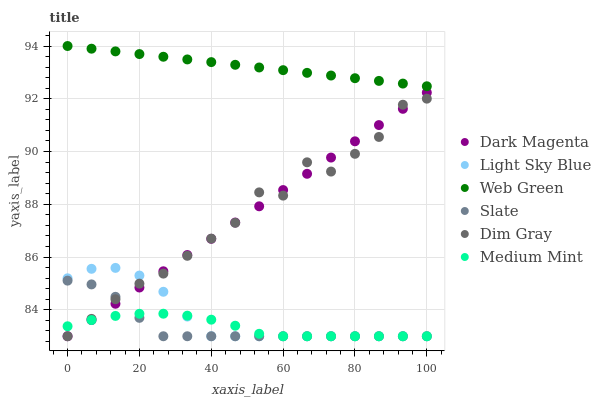Does Medium Mint have the minimum area under the curve?
Answer yes or no. Yes. Does Web Green have the maximum area under the curve?
Answer yes or no. Yes. Does Dim Gray have the minimum area under the curve?
Answer yes or no. No. Does Dim Gray have the maximum area under the curve?
Answer yes or no. No. Is Dark Magenta the smoothest?
Answer yes or no. Yes. Is Dim Gray the roughest?
Answer yes or no. Yes. Is Dim Gray the smoothest?
Answer yes or no. No. Is Dark Magenta the roughest?
Answer yes or no. No. Does Medium Mint have the lowest value?
Answer yes or no. Yes. Does Web Green have the lowest value?
Answer yes or no. No. Does Web Green have the highest value?
Answer yes or no. Yes. Does Dim Gray have the highest value?
Answer yes or no. No. Is Medium Mint less than Web Green?
Answer yes or no. Yes. Is Web Green greater than Light Sky Blue?
Answer yes or no. Yes. Does Light Sky Blue intersect Medium Mint?
Answer yes or no. Yes. Is Light Sky Blue less than Medium Mint?
Answer yes or no. No. Is Light Sky Blue greater than Medium Mint?
Answer yes or no. No. Does Medium Mint intersect Web Green?
Answer yes or no. No. 